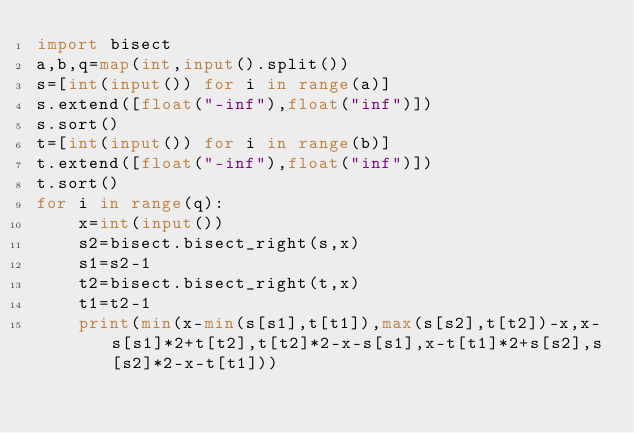Convert code to text. <code><loc_0><loc_0><loc_500><loc_500><_Python_>import bisect
a,b,q=map(int,input().split())
s=[int(input()) for i in range(a)]
s.extend([float("-inf"),float("inf")])
s.sort()
t=[int(input()) for i in range(b)]
t.extend([float("-inf"),float("inf")])
t.sort()
for i in range(q):
    x=int(input())
    s2=bisect.bisect_right(s,x)
    s1=s2-1
    t2=bisect.bisect_right(t,x)
    t1=t2-1
    print(min(x-min(s[s1],t[t1]),max(s[s2],t[t2])-x,x-s[s1]*2+t[t2],t[t2]*2-x-s[s1],x-t[t1]*2+s[s2],s[s2]*2-x-t[t1]))</code> 